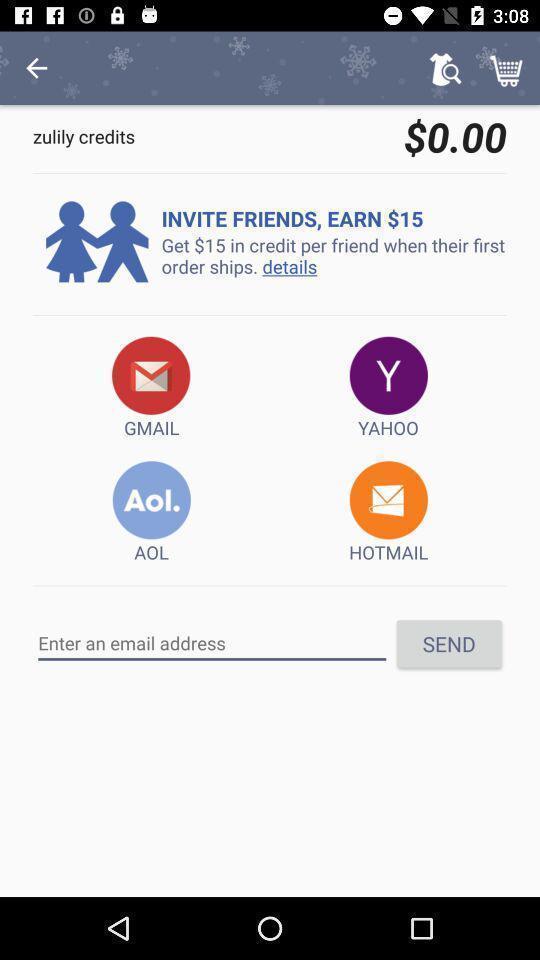What details can you identify in this image? Page showing invite option with different apps. 